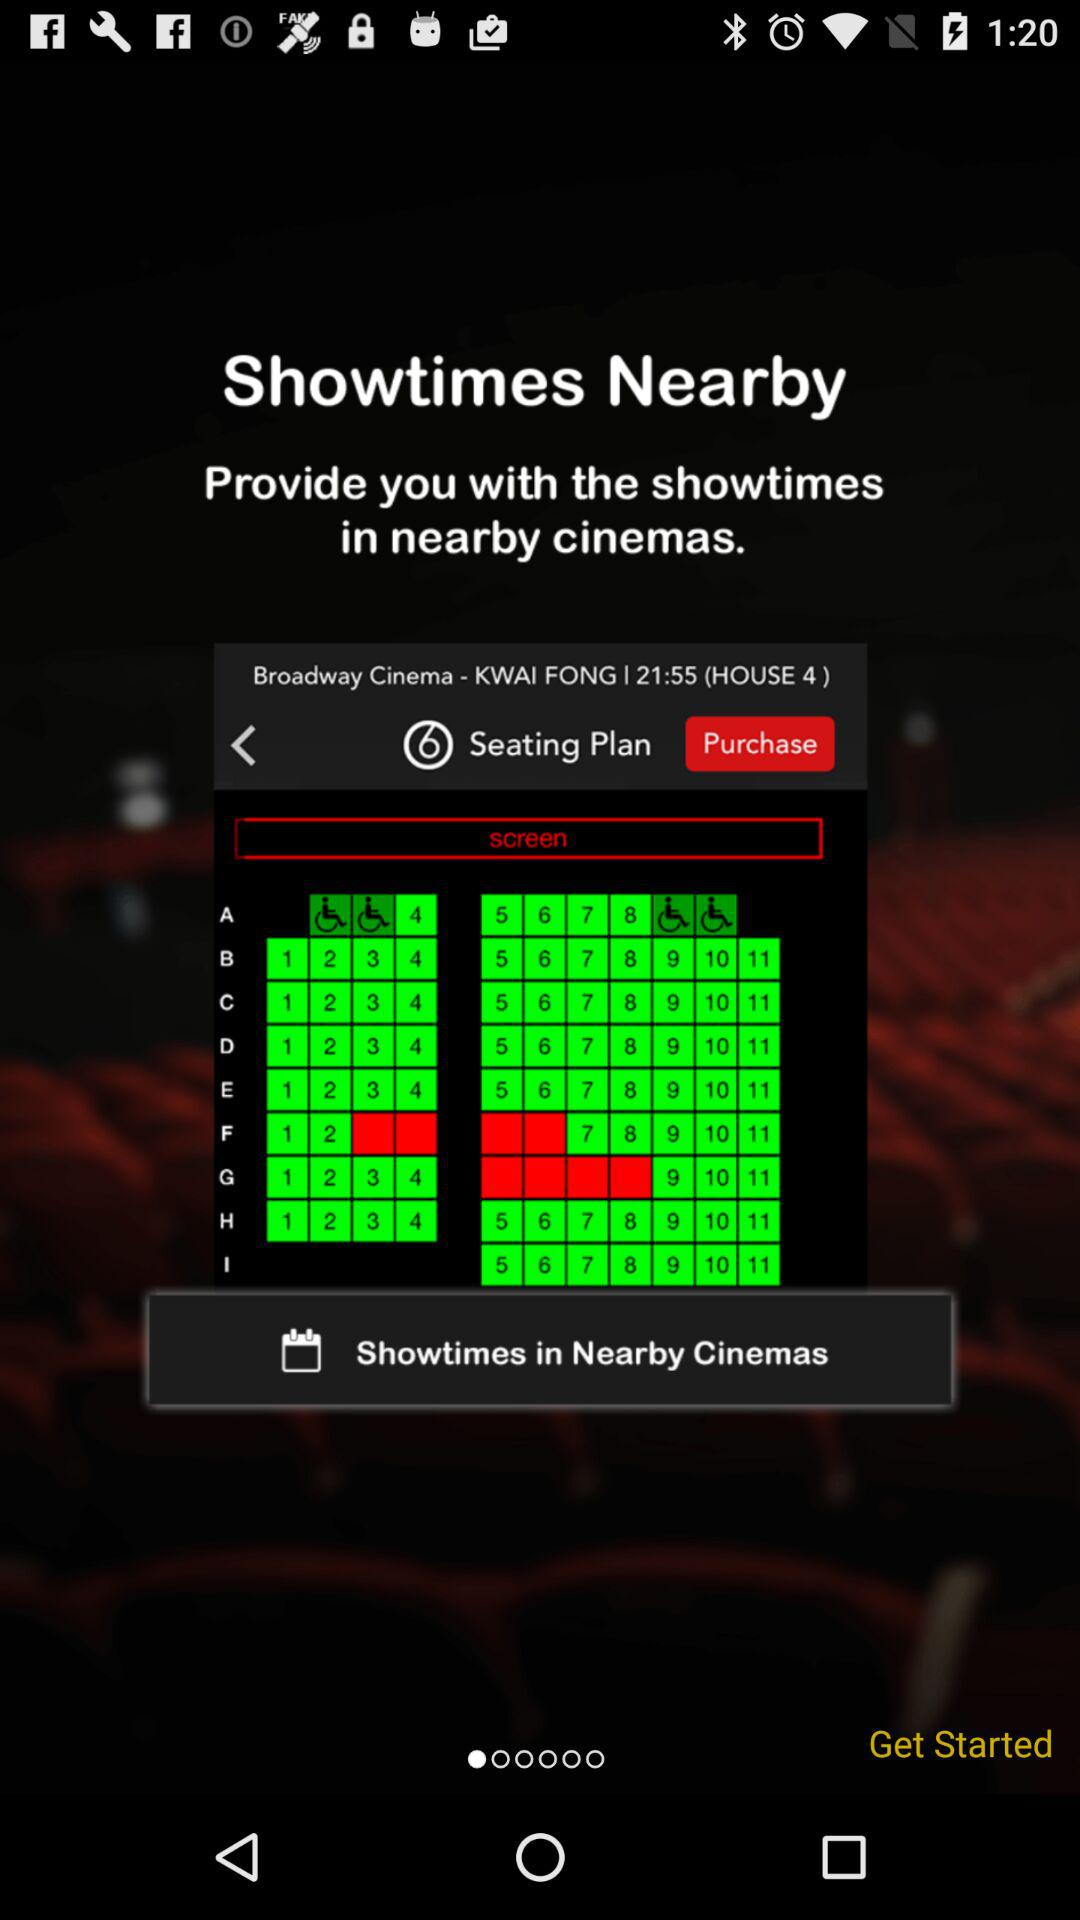What is the show time? The show time is 21:55. 